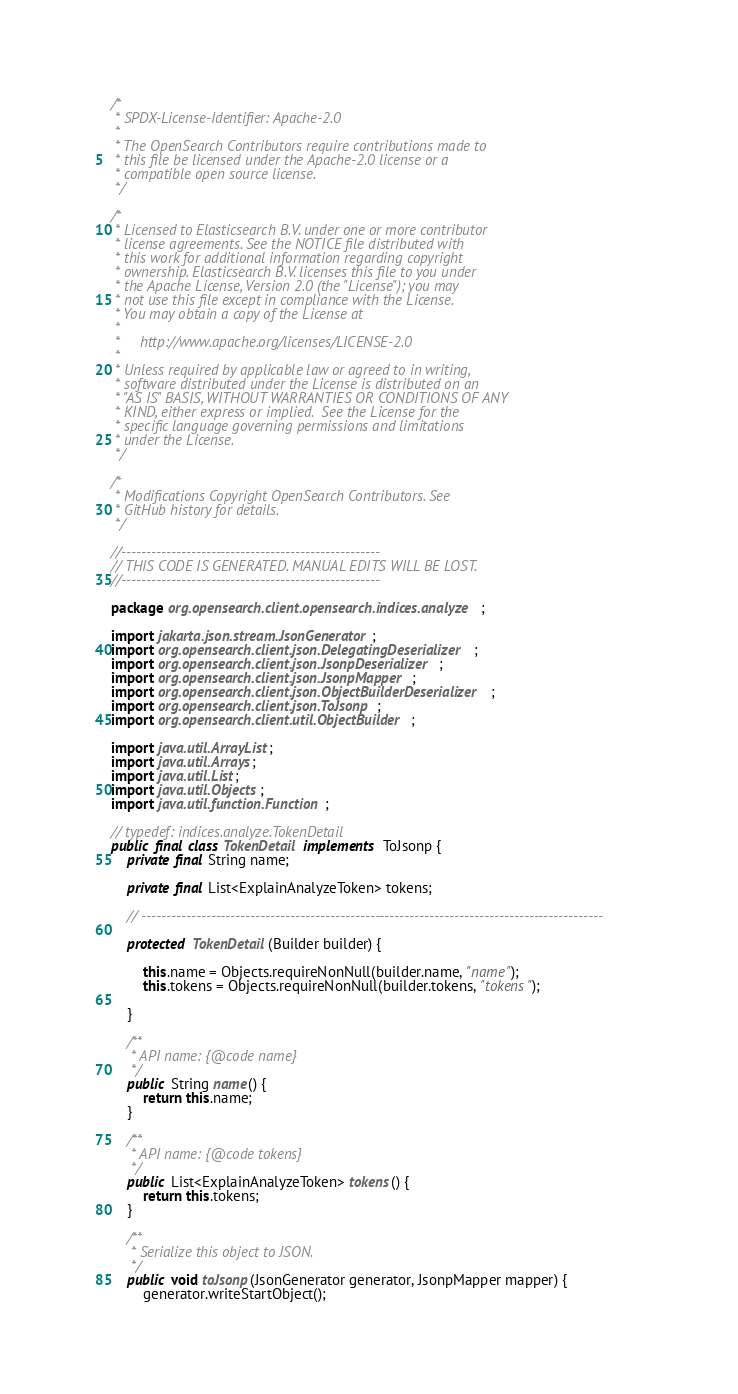<code> <loc_0><loc_0><loc_500><loc_500><_Java_>/*
 * SPDX-License-Identifier: Apache-2.0
 *
 * The OpenSearch Contributors require contributions made to
 * this file be licensed under the Apache-2.0 license or a
 * compatible open source license.
 */

/*
 * Licensed to Elasticsearch B.V. under one or more contributor
 * license agreements. See the NOTICE file distributed with
 * this work for additional information regarding copyright
 * ownership. Elasticsearch B.V. licenses this file to you under
 * the Apache License, Version 2.0 (the "License"); you may
 * not use this file except in compliance with the License.
 * You may obtain a copy of the License at
 *
 *     http://www.apache.org/licenses/LICENSE-2.0
 *
 * Unless required by applicable law or agreed to in writing,
 * software distributed under the License is distributed on an
 * "AS IS" BASIS, WITHOUT WARRANTIES OR CONDITIONS OF ANY
 * KIND, either express or implied.  See the License for the
 * specific language governing permissions and limitations
 * under the License.
 */

/*
 * Modifications Copyright OpenSearch Contributors. See
 * GitHub history for details.
 */

//----------------------------------------------------
// THIS CODE IS GENERATED. MANUAL EDITS WILL BE LOST.
//----------------------------------------------------

package org.opensearch.client.opensearch.indices.analyze;

import jakarta.json.stream.JsonGenerator;
import org.opensearch.client.json.DelegatingDeserializer;
import org.opensearch.client.json.JsonpDeserializer;
import org.opensearch.client.json.JsonpMapper;
import org.opensearch.client.json.ObjectBuilderDeserializer;
import org.opensearch.client.json.ToJsonp;
import org.opensearch.client.util.ObjectBuilder;

import java.util.ArrayList;
import java.util.Arrays;
import java.util.List;
import java.util.Objects;
import java.util.function.Function;

// typedef: indices.analyze.TokenDetail
public final class TokenDetail implements ToJsonp {
	private final String name;

	private final List<ExplainAnalyzeToken> tokens;

	// ---------------------------------------------------------------------------------------------

	protected TokenDetail(Builder builder) {

		this.name = Objects.requireNonNull(builder.name, "name");
		this.tokens = Objects.requireNonNull(builder.tokens, "tokens");

	}

	/**
	 * API name: {@code name}
	 */
	public String name() {
		return this.name;
	}

	/**
	 * API name: {@code tokens}
	 */
	public List<ExplainAnalyzeToken> tokens() {
		return this.tokens;
	}

	/**
	 * Serialize this object to JSON.
	 */
	public void toJsonp(JsonGenerator generator, JsonpMapper mapper) {
		generator.writeStartObject();</code> 